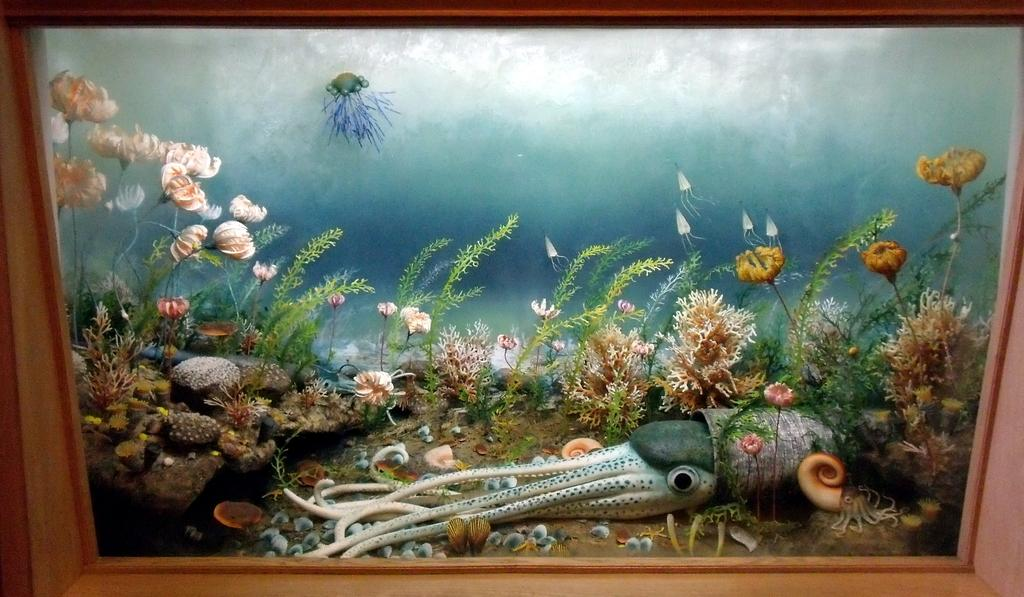What object is present in the picture? There is a photo frame in the picture. What is depicted in the photo frame? The photo frame contains an image of an underwater environment. What types of objects can be seen in the underwater environment? There are plants and rocks visible in the underwater environment. What type of marine animal is visible in the underwater environment? There is an octopus visible in the underwater environment. Where is the donkey located in the underwater environment? There is no donkey present in the underwater environment; the image only shows plants, rocks, and an octopus. 